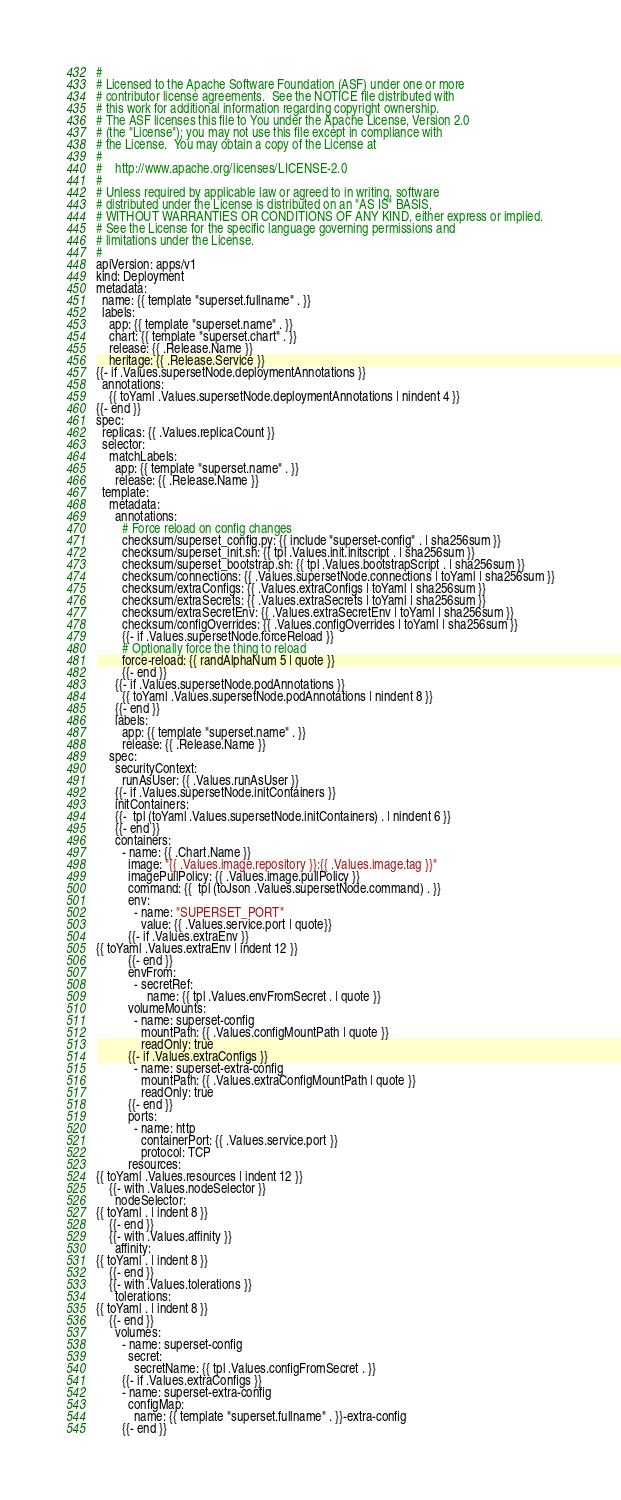Convert code to text. <code><loc_0><loc_0><loc_500><loc_500><_YAML_>#
# Licensed to the Apache Software Foundation (ASF) under one or more
# contributor license agreements.  See the NOTICE file distributed with
# this work for additional information regarding copyright ownership.
# The ASF licenses this file to You under the Apache License, Version 2.0
# (the "License"); you may not use this file except in compliance with
# the License.  You may obtain a copy of the License at
#
#    http://www.apache.org/licenses/LICENSE-2.0
#
# Unless required by applicable law or agreed to in writing, software
# distributed under the License is distributed on an "AS IS" BASIS,
# WITHOUT WARRANTIES OR CONDITIONS OF ANY KIND, either express or implied.
# See the License for the specific language governing permissions and
# limitations under the License.
#
apiVersion: apps/v1
kind: Deployment
metadata:
  name: {{ template "superset.fullname" . }}
  labels:
    app: {{ template "superset.name" . }}
    chart: {{ template "superset.chart" . }}
    release: {{ .Release.Name }}
    heritage: {{ .Release.Service }}
{{- if .Values.supersetNode.deploymentAnnotations }}
  annotations:
    {{ toYaml .Values.supersetNode.deploymentAnnotations | nindent 4 }}
{{- end }}
spec:
  replicas: {{ .Values.replicaCount }}
  selector:
    matchLabels:
      app: {{ template "superset.name" . }}
      release: {{ .Release.Name }}
  template:
    metadata:
      annotations:
        # Force reload on config changes
        checksum/superset_config.py: {{ include "superset-config" . | sha256sum }}
        checksum/superset_init.sh: {{ tpl .Values.init.initscript . | sha256sum }}
        checksum/superset_bootstrap.sh: {{ tpl .Values.bootstrapScript . | sha256sum }}
        checksum/connections: {{ .Values.supersetNode.connections | toYaml | sha256sum }}
        checksum/extraConfigs: {{ .Values.extraConfigs | toYaml | sha256sum }}
        checksum/extraSecrets: {{ .Values.extraSecrets | toYaml | sha256sum }}
        checksum/extraSecretEnv: {{ .Values.extraSecretEnv | toYaml | sha256sum }}
        checksum/configOverrides: {{ .Values.configOverrides | toYaml | sha256sum }}
        {{- if .Values.supersetNode.forceReload }}
        # Optionally force the thing to reload
        force-reload: {{ randAlphaNum 5 | quote }}
        {{- end }}
      {{- if .Values.supersetNode.podAnnotations }}
        {{ toYaml .Values.supersetNode.podAnnotations | nindent 8 }}
      {{- end }}
      labels:
        app: {{ template "superset.name" . }}
        release: {{ .Release.Name }}
    spec:
      securityContext:
        runAsUser: {{ .Values.runAsUser }}
      {{- if .Values.supersetNode.initContainers }}
      initContainers:
      {{-  tpl (toYaml .Values.supersetNode.initContainers) . | nindent 6 }}
      {{- end }}
      containers:
        - name: {{ .Chart.Name }}
          image: "{{ .Values.image.repository }}:{{ .Values.image.tag }}"
          imagePullPolicy: {{ .Values.image.pullPolicy }}
          command: {{  tpl (toJson .Values.supersetNode.command) . }}
          env:
            - name: "SUPERSET_PORT"
              value: {{ .Values.service.port | quote}}
          {{- if .Values.extraEnv }}
{{ toYaml .Values.extraEnv | indent 12 }}
          {{- end }}
          envFrom:
            - secretRef:
                name: {{ tpl .Values.envFromSecret . | quote }}
          volumeMounts:
            - name: superset-config
              mountPath: {{ .Values.configMountPath | quote }}
              readOnly: true
          {{- if .Values.extraConfigs }}
            - name: superset-extra-config
              mountPath: {{ .Values.extraConfigMountPath | quote }}
              readOnly: true
          {{- end }}
          ports:
            - name: http
              containerPort: {{ .Values.service.port }}
              protocol: TCP
          resources:
{{ toYaml .Values.resources | indent 12 }}
    {{- with .Values.nodeSelector }}
      nodeSelector:
{{ toYaml . | indent 8 }}
    {{- end }}
    {{- with .Values.affinity }}
      affinity:
{{ toYaml . | indent 8 }}
    {{- end }}
    {{- with .Values.tolerations }}
      tolerations:
{{ toYaml . | indent 8 }}
    {{- end }}
      volumes:
        - name: superset-config
          secret:
            secretName: {{ tpl .Values.configFromSecret . }}
        {{- if .Values.extraConfigs }}
        - name: superset-extra-config
          configMap:
            name: {{ template "superset.fullname" . }}-extra-config
        {{- end }}
</code> 